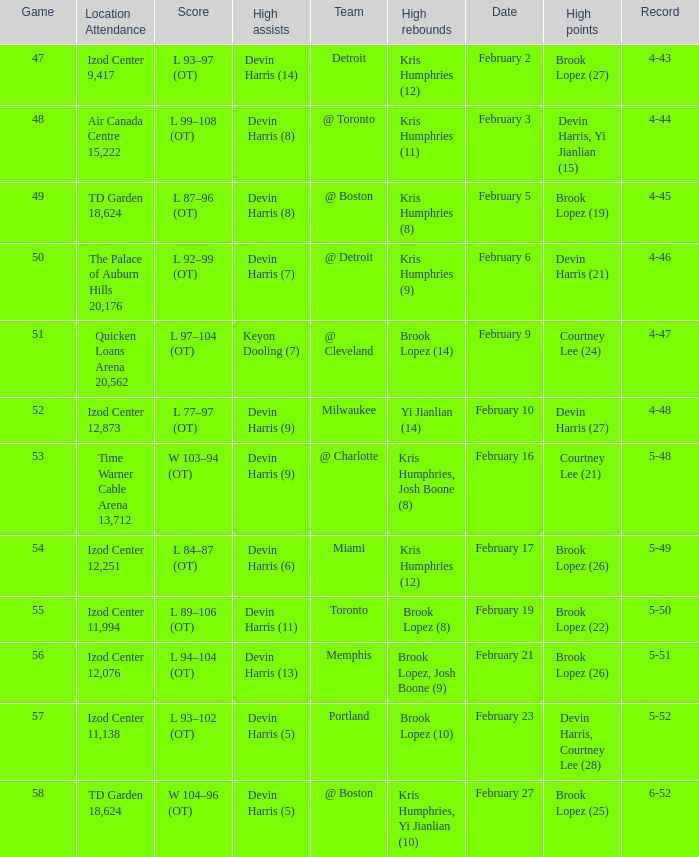What was the record in the game against Memphis? 5-51. 